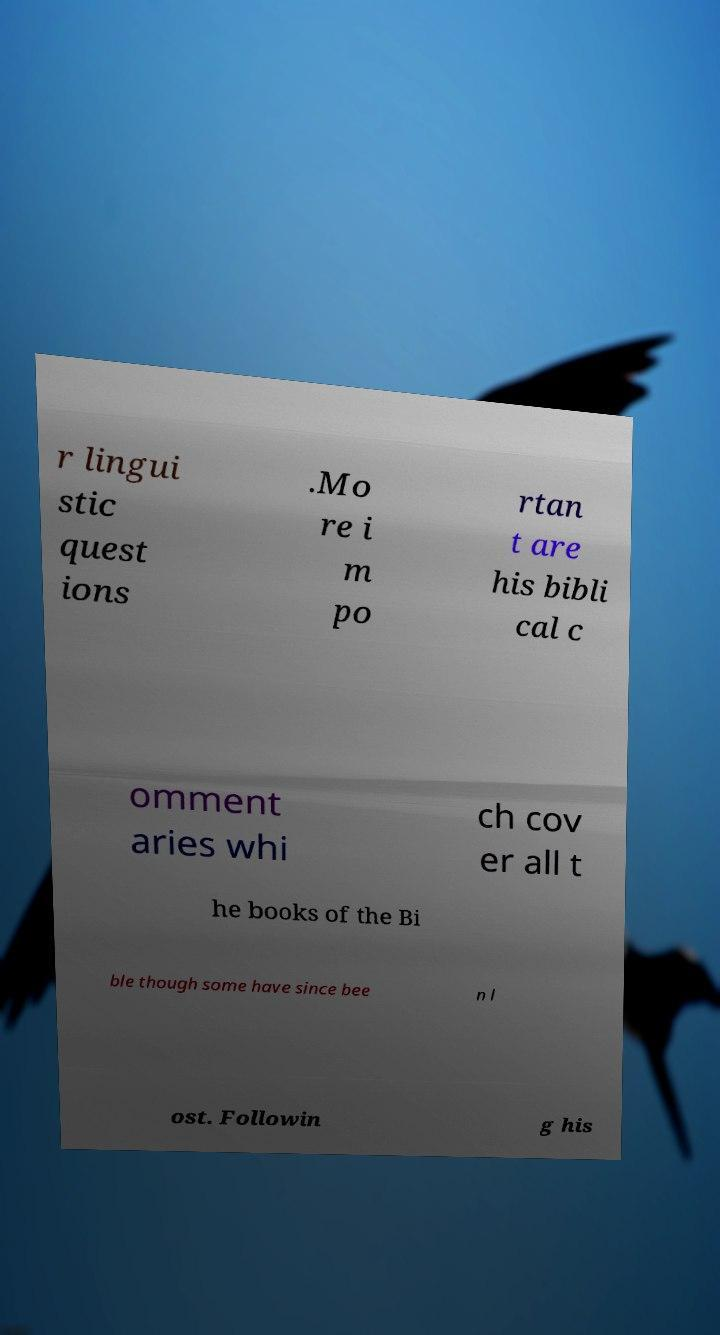Could you assist in decoding the text presented in this image and type it out clearly? r lingui stic quest ions .Mo re i m po rtan t are his bibli cal c omment aries whi ch cov er all t he books of the Bi ble though some have since bee n l ost. Followin g his 